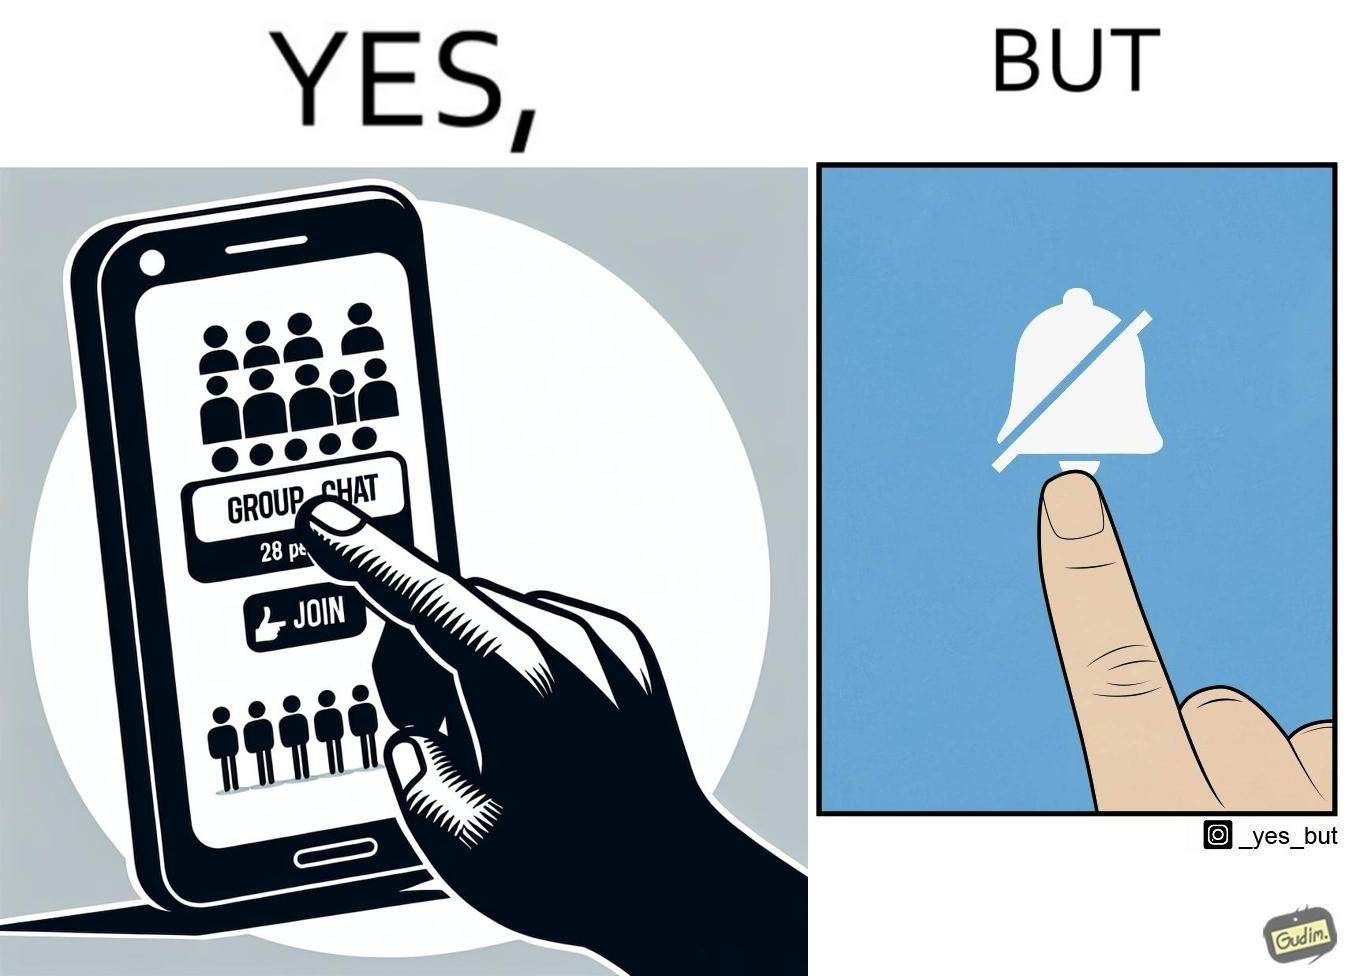Why is this image considered satirical? This is ironic because the person joining the big social group, presumably interested in the happenings of that group, motivated to engage with these people, MUTEs the group as soon as they join it, indicating they are not interested in it and do not  want to be bothered by it.  These actions are contradictory from a social perspective, and illuminate a weird fact about present day online life. 